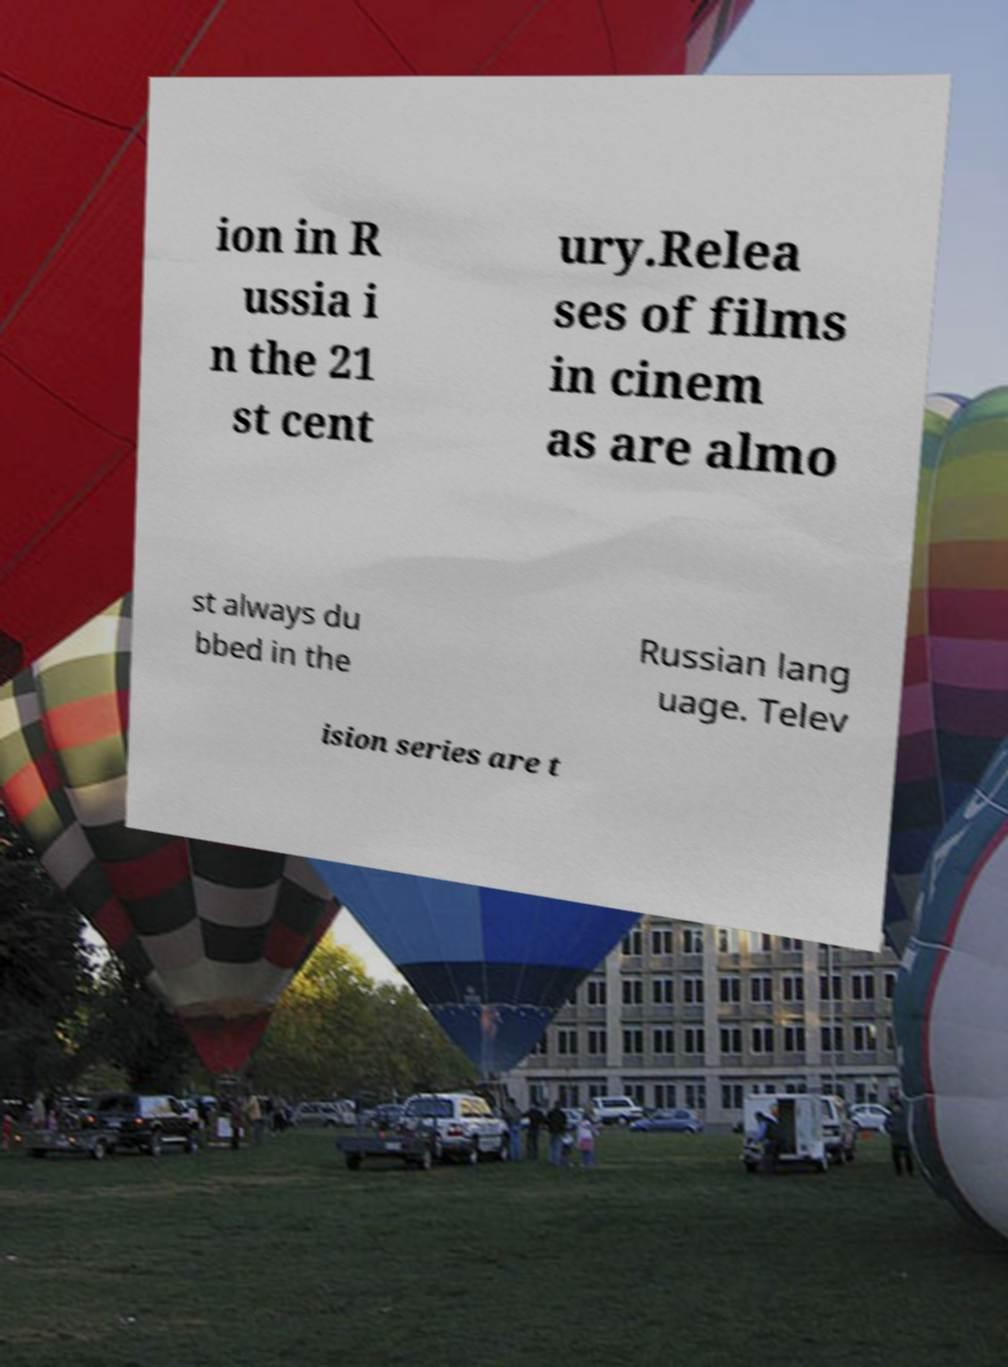For documentation purposes, I need the text within this image transcribed. Could you provide that? ion in R ussia i n the 21 st cent ury.Relea ses of films in cinem as are almo st always du bbed in the Russian lang uage. Telev ision series are t 